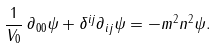Convert formula to latex. <formula><loc_0><loc_0><loc_500><loc_500>\frac { 1 } { V _ { 0 } } \, \partial _ { 0 0 } \psi + \delta ^ { i j } \partial _ { i j } \psi = - m ^ { 2 } n ^ { 2 } \psi .</formula> 